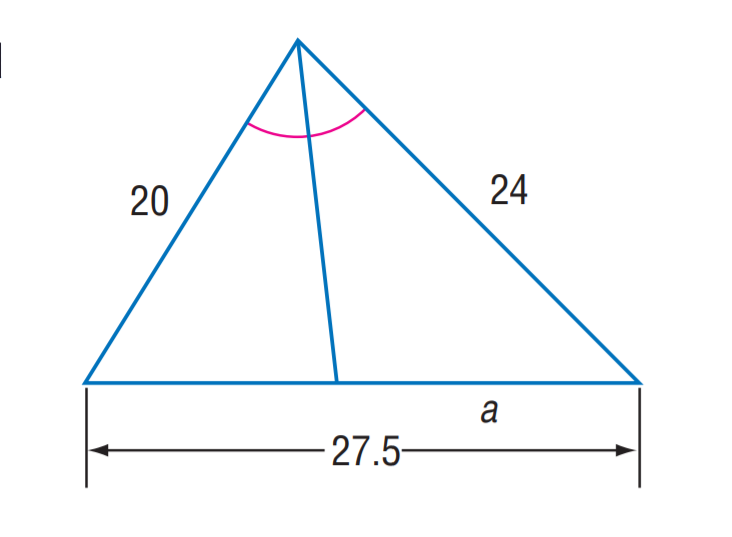Question: Find a.
Choices:
A. 12
B. 12.5
C. 15
D. 17.5
Answer with the letter. Answer: C 